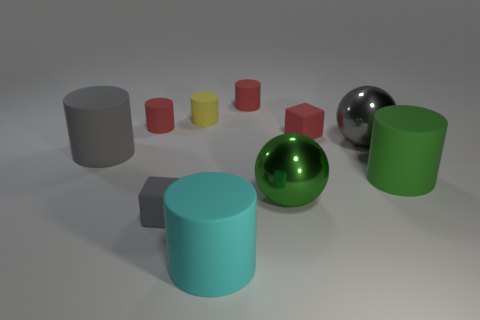Subtract all cyan cylinders. How many cylinders are left? 5 Subtract all purple blocks. How many red cylinders are left? 2 Subtract all gray cylinders. How many cylinders are left? 5 Subtract all blocks. How many objects are left? 8 Add 1 green spheres. How many green spheres are left? 2 Add 5 matte blocks. How many matte blocks exist? 7 Subtract 1 green cylinders. How many objects are left? 9 Subtract all red cylinders. Subtract all red spheres. How many cylinders are left? 4 Subtract all small matte cylinders. Subtract all big cyan rubber cylinders. How many objects are left? 6 